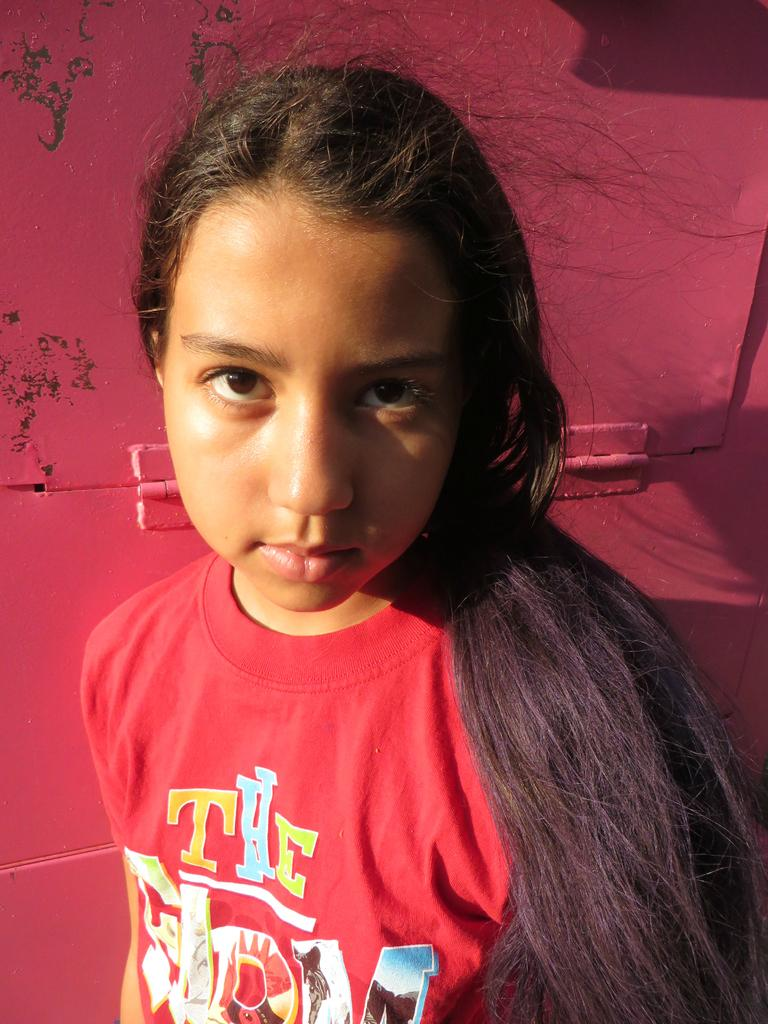<image>
Describe the image concisely. A girl with long dark hair is wearing a red shirt that says The Farm. 